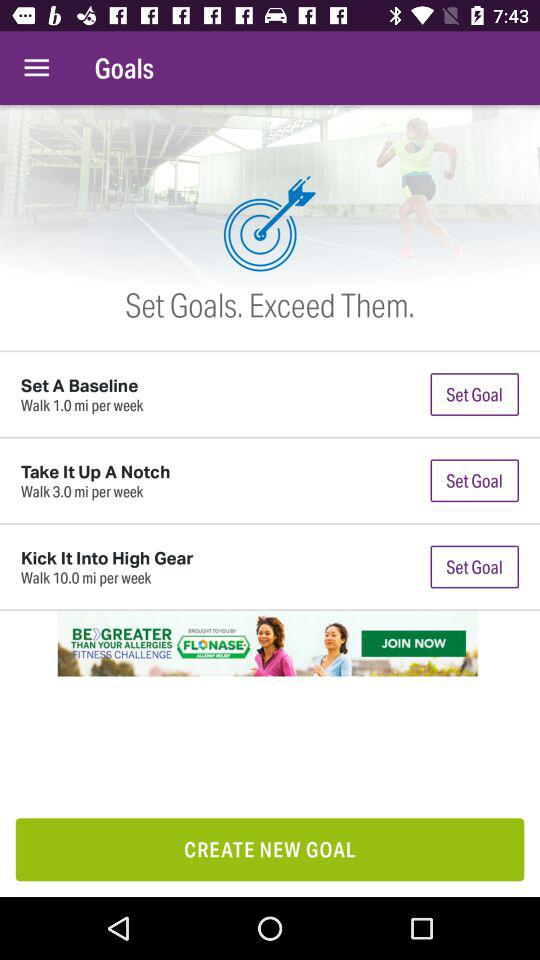How many more miles per week is the Kick It Into High Gear goal than the Set A Baseline goal?
Answer the question using a single word or phrase. 9 